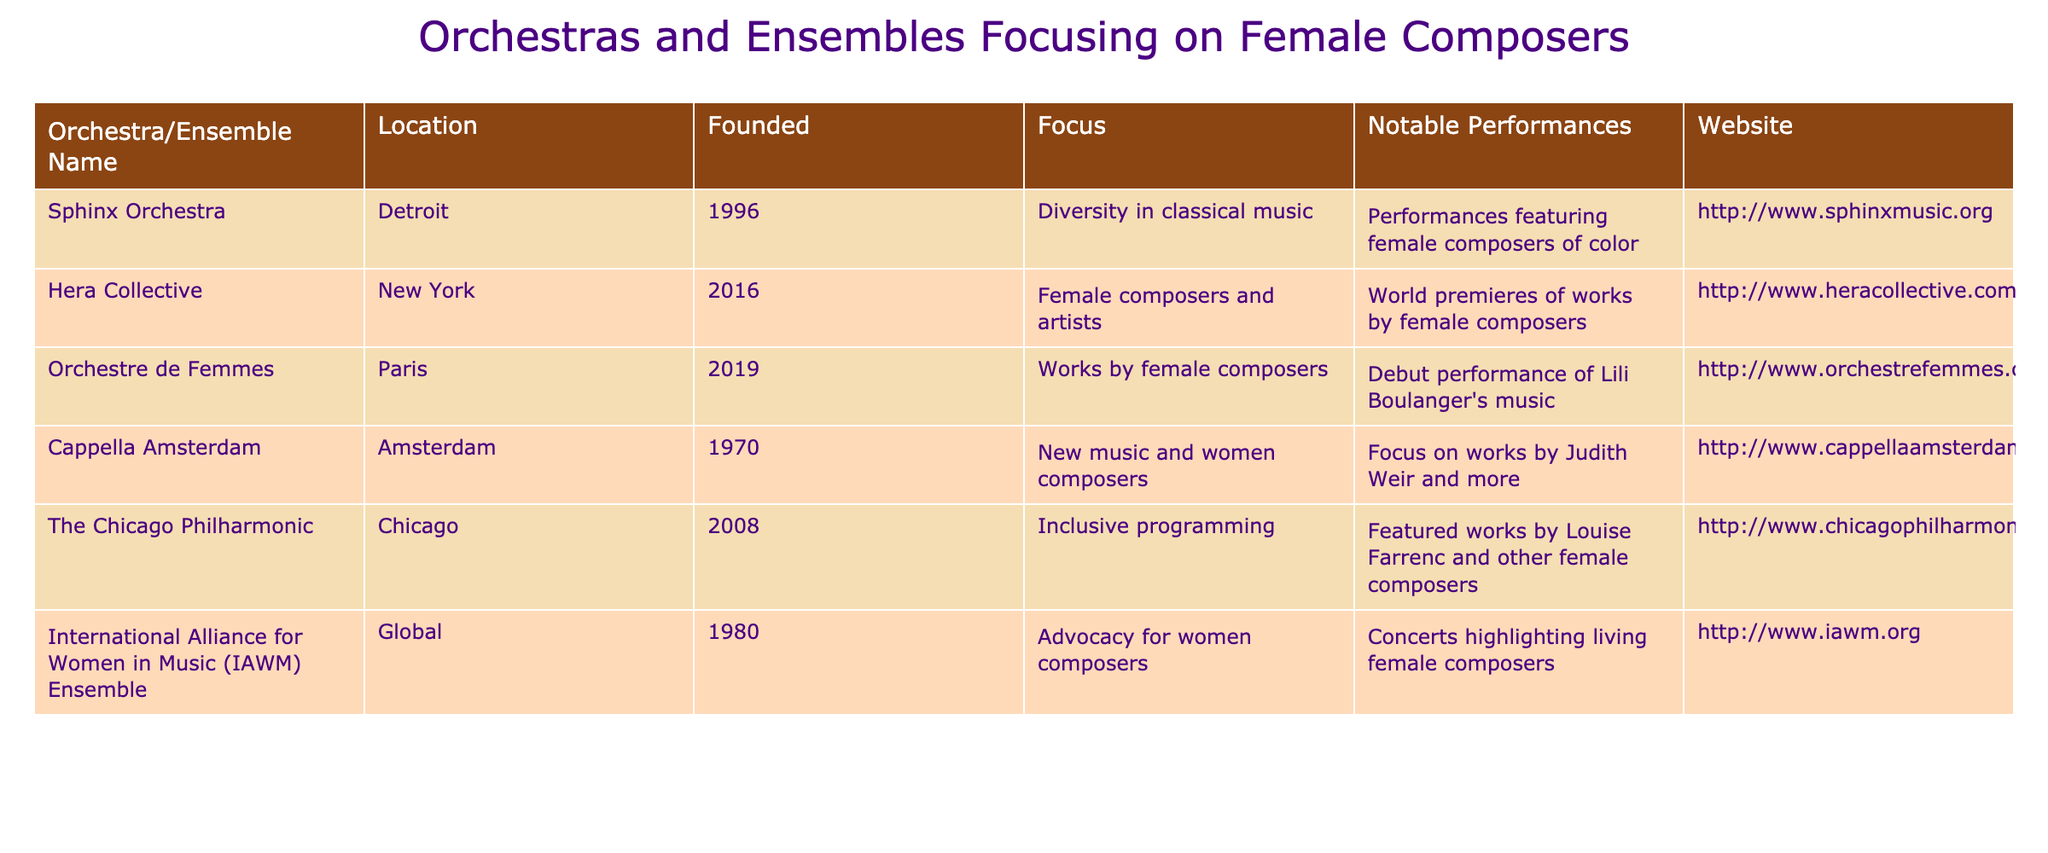What year was the Sphinx Orchestra founded? The table provides specific information for each orchestra, including the year they were founded. Looking at the row for the Sphinx Orchestra, it shows that it was founded in 1996.
Answer: 1996 Which orchestra has a focus on diversity in classical music? By examining the "Focus" column for each orchestra, we find that the Sphinx Orchestra explicitly mentions "Diversity in classical music" as its focus.
Answer: Sphinx Orchestra How many orchestras were founded in the 2000s or later? We can identify the orchestras by focusing on the "Founded" column. The orchestras founded in the 2000s or later are the Chicago Philharmonic (2008), Hera Collective (2016), and Orchestre de Femmes (2019), totaling three orchestras.
Answer: 3 Is the International Alliance for Women in Music (IAWM) Ensemble based in a specific location? The table lists the IAWM Ensemble as "Global," indicating it does not have a specific geographical location associated with it. Therefore, the answer is no, it is not based in a specific location.
Answer: No What notable performance is associated with the Hera Collective? Referring to the "Notable Performances" column for the Hera Collective, it is noted for world premieres of works by female composers, which is considered a significant and notable performance associated with the ensemble.
Answer: World premieres of works by female composers Which two orchestras focus specifically on works by female composers? The relevant entries in the "Focus" column indicate that both the Hera Collective and Orchestre de Femmes focus specifically on works by female composers or related activities. Hence, they are the two orchestras that match this criterion.
Answer: Hera Collective, Orchestre de Femmes What is the total number of orchestras listed in the table? By counting the entries in the table without skipping any rows, we find there are six orchestras in total.
Answer: 6 Which orchestra focuses on living female composers? Looking at the "Focus" column for each orchestra, the International Alliance for Women in Music (IAWM) Ensemble mentions advocacy for women composers and highlights living female composers as part of its focus.
Answer: IAWM Ensemble How many orchestras were founded before the year 2000? To find the orchestras founded before 2000, we review the "Founded" column. The founded years are: Sphinx Orchestra (1996), Cappella Amsterdam (1970), and IAWM Ensemble (1980). This gives us a total of three orchestras founded before 2000.
Answer: 3 